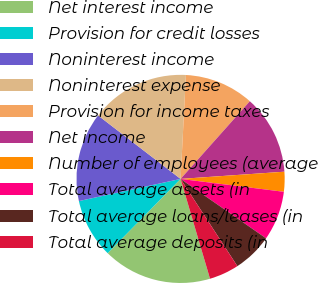Convert chart to OTSL. <chart><loc_0><loc_0><loc_500><loc_500><pie_chart><fcel>Net interest income<fcel>Provision for credit losses<fcel>Noninterest income<fcel>Noninterest expense<fcel>Provision for income taxes<fcel>Net income<fcel>Number of employees (average<fcel>Total average assets (in<fcel>Total average loans/leases (in<fcel>Total average deposits (in<nl><fcel>16.92%<fcel>9.23%<fcel>13.85%<fcel>15.38%<fcel>10.77%<fcel>12.31%<fcel>3.08%<fcel>7.69%<fcel>6.15%<fcel>4.62%<nl></chart> 